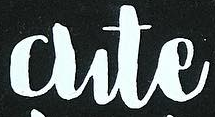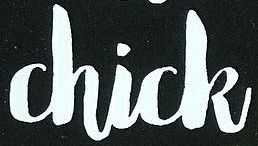Transcribe the words shown in these images in order, separated by a semicolon. Cute; Chick 